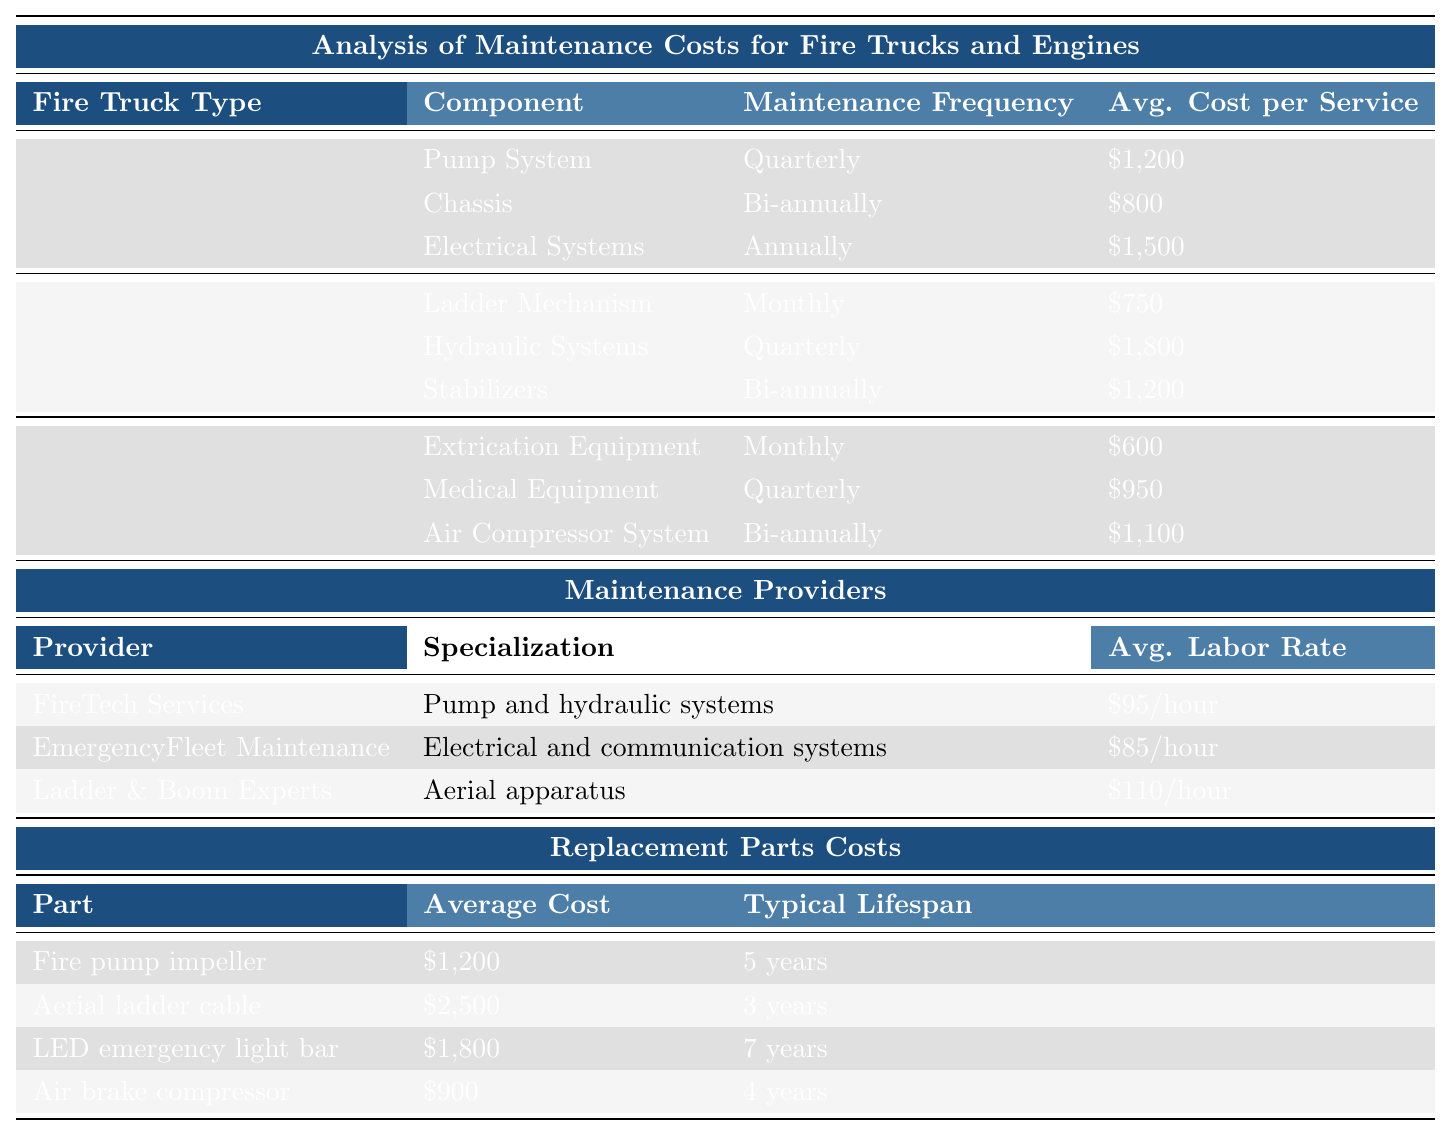What is the annual maintenance cost of a Pumper Truck? The table lists the annual maintenance cost for a Pumper Truck as $12,500.
Answer: $12,500 How often does the pump system maintenance occur for a Pumper Truck? According to the table, the pump system for a Pumper Truck is maintained quarterly.
Answer: Quarterly What is the average cost per service for the Electrical Systems in a Pumper Truck? The table states that the average cost per service for the Electrical Systems in a Pumper Truck is $1,500.
Answer: $1,500 Which fire truck type has the highest annual maintenance cost? By comparing the annual maintenance costs: Pumper Truck at $12,500, Aerial Ladder Truck at $18,000, and Rescue Engine at $15,500, the Aerial Ladder Truck has the highest cost.
Answer: Aerial Ladder Truck What is the total annual maintenance cost for all three types of fire trucks? The annual costs are $12,500 (Pumper Truck) + $18,000 (Aerial Ladder Truck) + $15,500 (Rescue Engine) = $46,000, which represents the total.
Answer: $46,000 How much does it cost to service the Hydraulic Systems in an Aerial Ladder Truck? The table indicates that servicing the Hydraulic Systems in an Aerial Ladder Truck costs $1,800.
Answer: $1,800 What is the average labor rate of the provider that specializes in aerial apparatus? The table shows that Ladder & Boom Experts, which specializes in aerial apparatus, has an average labor rate of $110/hour.
Answer: $110/hour Is the maintenance frequency for the Air Compressor System in a Rescue Engine monthly? Reviewing the table, the Air Compressor System in a Rescue Engine has a maintenance frequency listed as bi-annually, which means the statement is false.
Answer: No What component of the Aerial Ladder Truck has the lowest average cost per service? The comparisons show that the Ladder Mechanism costs $750, the Hydraulic Systems cost $1,800, and the Stabilizers cost $1,200. Thus, the Ladder Mechanism has the lowest cost.
Answer: Ladder Mechanism If the LED emergency light bar has a lifespan of 7 years, what is the average yearly cost to maintain it? The average cost is $1,800, and over 7 years, the yearly cost would be $1,800 / 7 = $257.14.
Answer: $257.14 